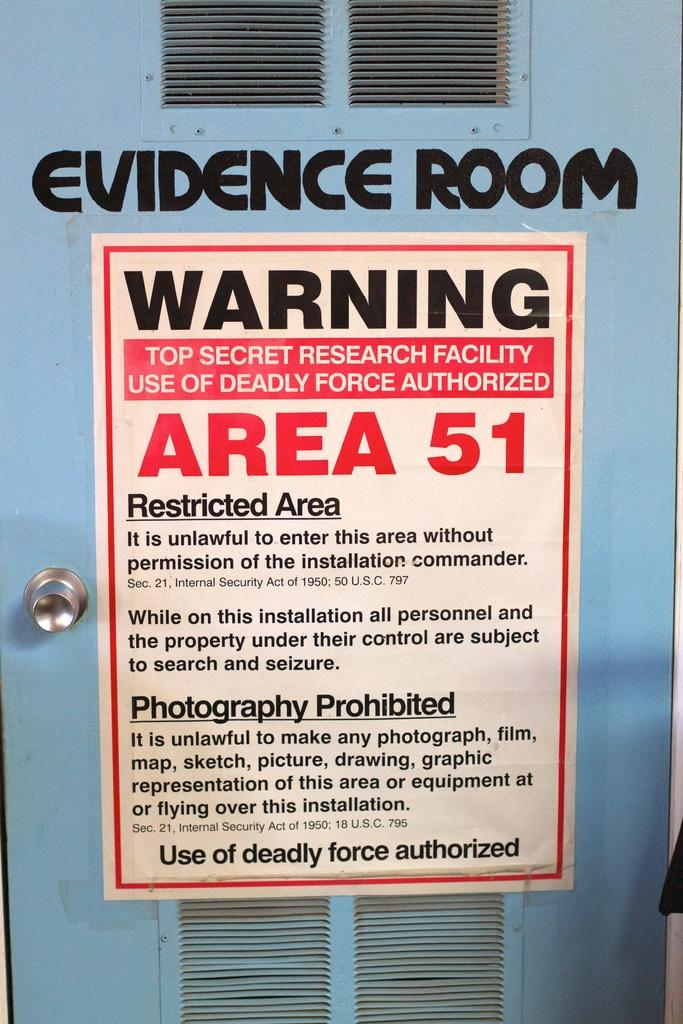<image>
Give a short and clear explanation of the subsequent image. blue door marked evidence room with a sign below warning top secret research facility use of deadly force authorized 